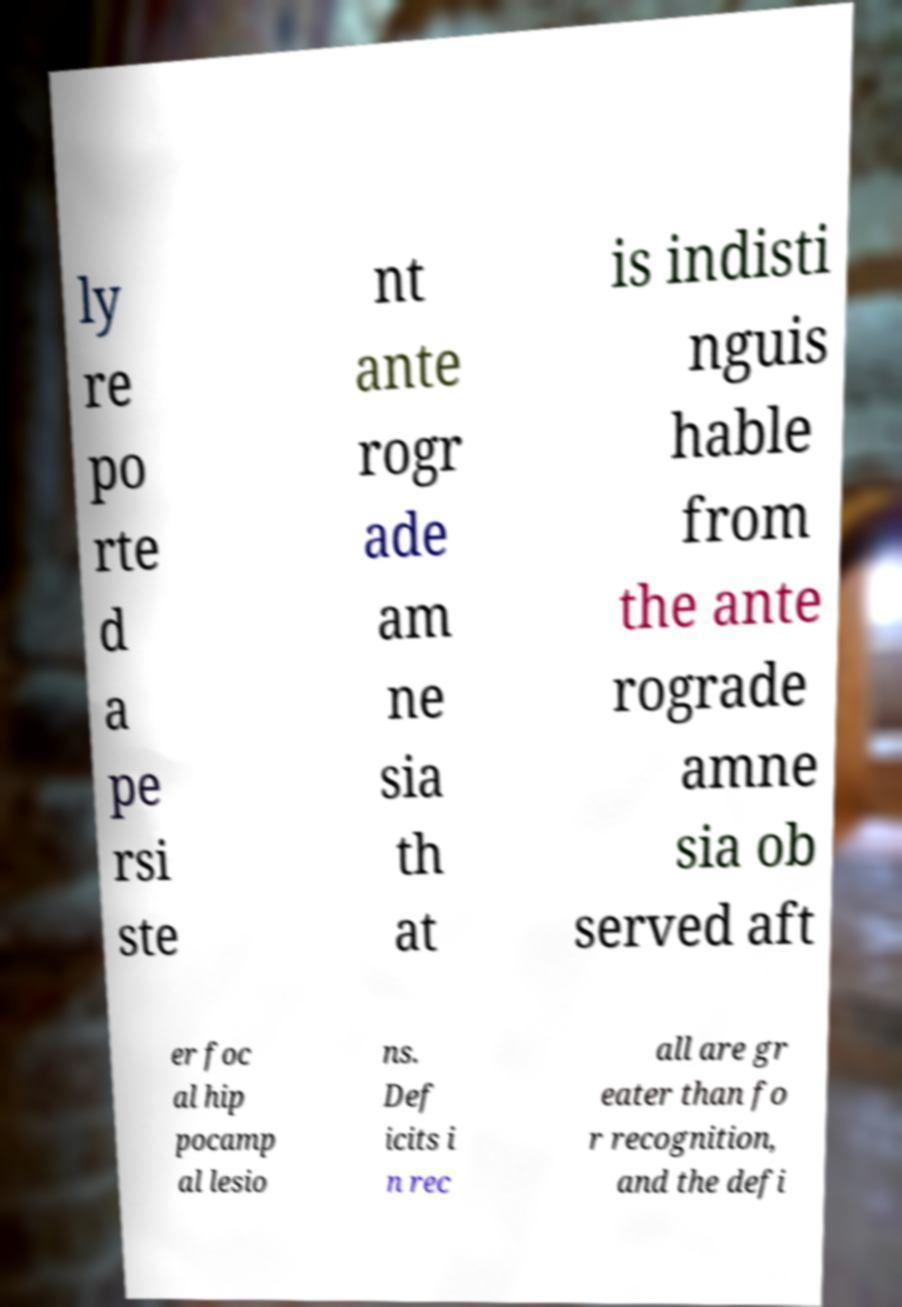Could you assist in decoding the text presented in this image and type it out clearly? ly re po rte d a pe rsi ste nt ante rogr ade am ne sia th at is indisti nguis hable from the ante rograde amne sia ob served aft er foc al hip pocamp al lesio ns. Def icits i n rec all are gr eater than fo r recognition, and the defi 